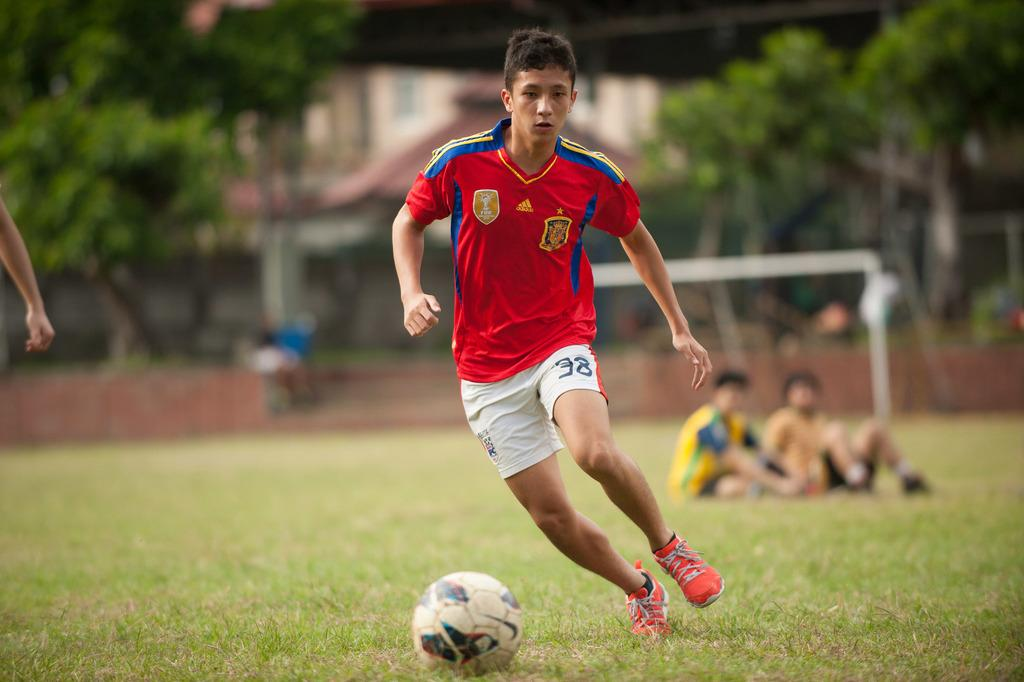Who is the main subject in the image? There is a boy in the image. What is the boy trying to do in the image? The boy is trying to hit a ball in the image. Where is the ball located in the image? The ball is in the grass in the image. Can you describe the people in the image? There are two people sitting in the image. What type of natural environment is visible in the image? There are trees in the image. What type of plate is being used to catch the ball in the image? There is no plate present in the image, and the boy is trying to hit the ball, not catch it. 